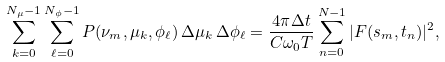Convert formula to latex. <formula><loc_0><loc_0><loc_500><loc_500>\sum _ { k = 0 } ^ { N _ { \mu } - 1 } \sum _ { \ell = 0 } ^ { N _ { \phi } - 1 } P ( \nu _ { m } , \mu _ { k } , \phi _ { \ell } ) \, \Delta \mu _ { k } \, \Delta \phi _ { \ell } = \frac { 4 \pi \Delta t } { C \omega _ { 0 } T } \sum _ { n = 0 } ^ { N - 1 } | F ( s _ { m } , t _ { n } ) | ^ { 2 } ,</formula> 